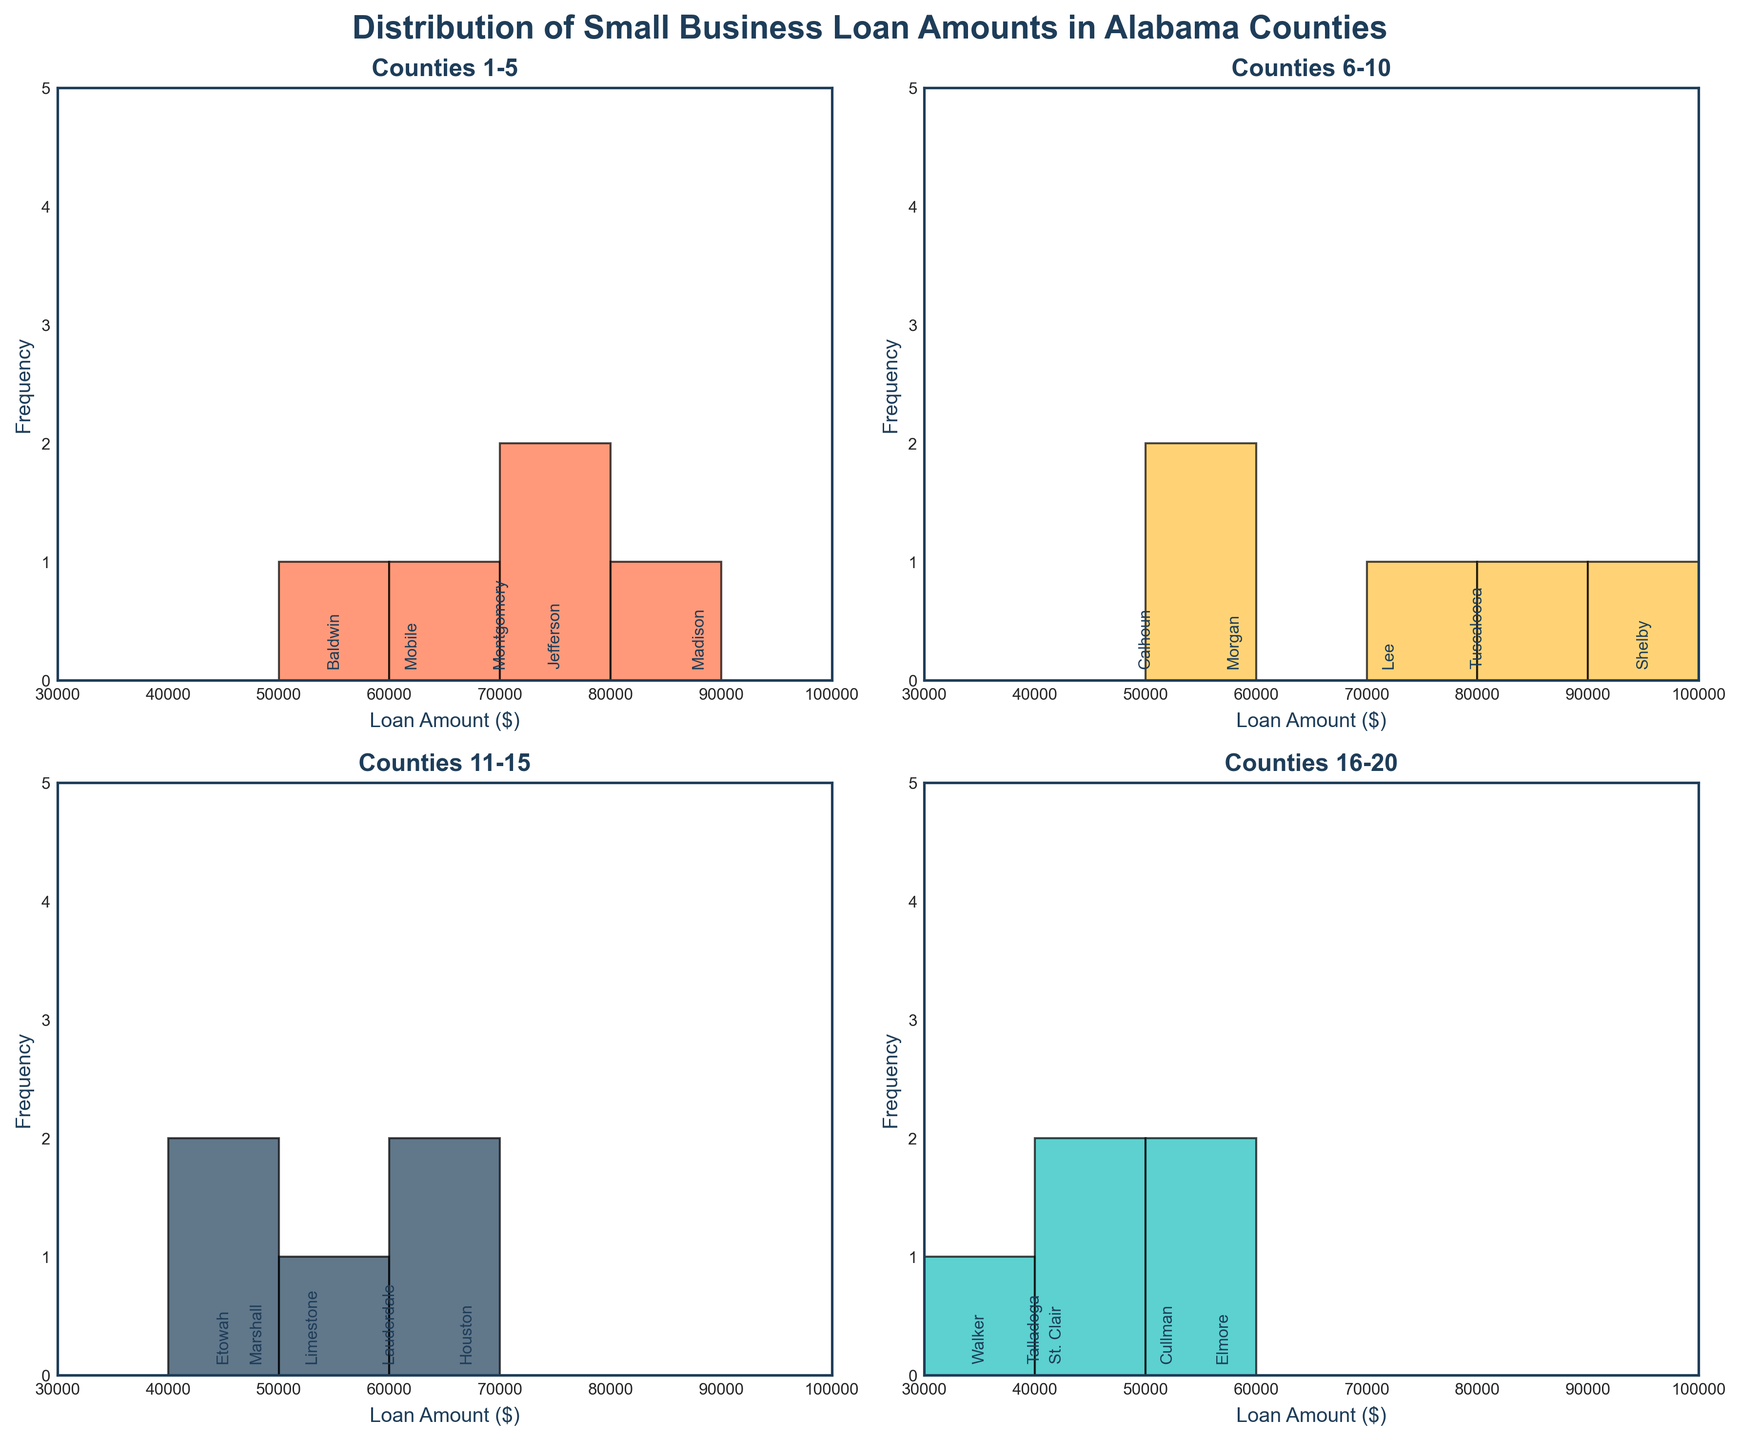what is the title of the plot? The title of the plot is located at the top center of the figure and provides a summary of the content displayed.
Answer: Distribution of Small Business Loan Amounts in Alabama Counties what are the x-axis labels representing? The x-axis labels represent different ranges of loan amounts approved for small businesses in Alabama counties, denoted in dollars.
Answer: Loan Amount ($) how many subplots are in the figure? The figure consists of 4 separate histograms, arranged in a 2x2 grid.
Answer: 4 how many counties are shown in each subplot? Each histogram within the figure comprises data for 5 counties.
Answer: 5 which subplot represents loan amounts for counties Shelby through Walker? The subset of counties from Shelby through Walker falls within the 4th subplot as arranged sequentially in the dataset.
Answer: Counties 16-20 which county received a loan amount of $95,000? The subplot title labeled “Counties 16-20” shows the loan amounts, among which Shelby received $95,000.
Answer: Shelby which color represents the last subplot? In the 2x2 grid of histograms, the last subplot is colored with the fourth color in sequence, '#17BEBB'.
Answer: '#17BEBB' what is the highest loan amount in the second histogram? Examining the second subplot (Counties 6-10), the highest loan amount recorded is $95,000 from Shelby.
Answer: $95,000 how many counties have loan amounts below $50,000 in the whole figure? By counting each subplot that lists smaller loan amounts, the counties are Talladega (40,000) and Walker (35,000) in the last subplot, St. Clair (42,000) and Marshall (48,000) in the third subplot and Etowah (45,000) in the second subplot.
Answer: 5 which loan amount range has the highest frequency? Upon analyzing all subplots, the range of $40,000 - $50,000 has the highest singular frequency of data points when counting the counties in all subplots with loan amounts within this range.
Answer: $40,000 - $50,000 